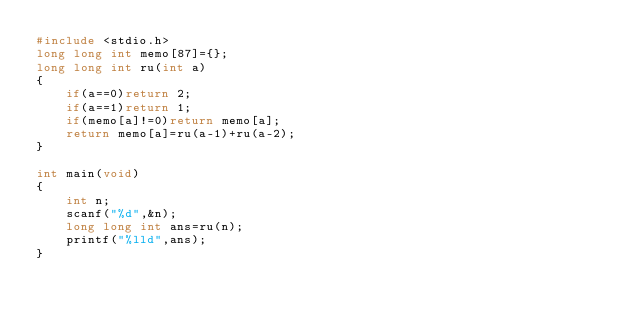<code> <loc_0><loc_0><loc_500><loc_500><_C_>#include <stdio.h>
long long int memo[87]={};
long long int ru(int a)
{
    if(a==0)return 2;
    if(a==1)return 1;
    if(memo[a]!=0)return memo[a];
    return memo[a]=ru(a-1)+ru(a-2);
}

int main(void)
{
    int n;
    scanf("%d",&n);
    long long int ans=ru(n);
    printf("%lld",ans);
}
</code> 